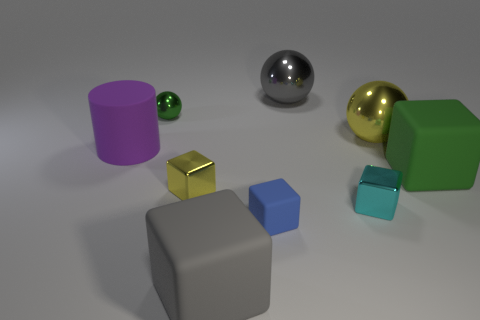There is a big matte object that is the same color as the tiny metal sphere; what shape is it?
Your answer should be very brief. Cube. Is there a yellow cylinder made of the same material as the big yellow ball?
Ensure brevity in your answer.  No. Are the tiny block on the right side of the small blue thing and the yellow object that is behind the large rubber cylinder made of the same material?
Your answer should be compact. Yes. Are there an equal number of gray blocks that are behind the gray matte cube and large rubber cubes that are to the right of the large yellow metallic thing?
Offer a terse response. No. There is a cylinder that is the same size as the gray matte cube; what is its color?
Make the answer very short. Purple. Are there any large rubber cylinders of the same color as the small matte block?
Provide a short and direct response. No. What number of objects are either yellow metal things that are behind the purple rubber thing or cyan blocks?
Offer a terse response. 2. How many other objects are there of the same size as the cyan shiny thing?
Make the answer very short. 3. What material is the gray object that is in front of the big cube on the right side of the block that is in front of the tiny blue rubber cube?
Ensure brevity in your answer.  Rubber. How many balls are either tiny yellow metal objects or big metallic things?
Keep it short and to the point. 2. 